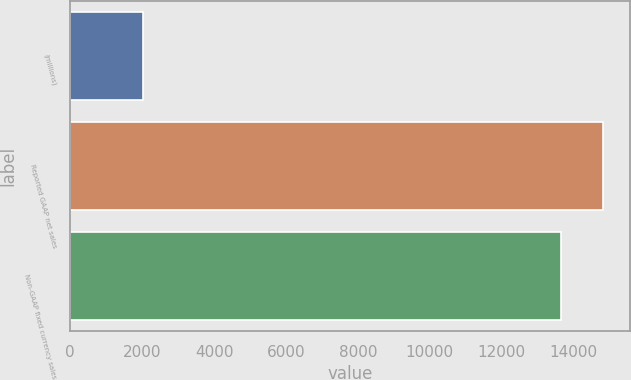Convert chart. <chart><loc_0><loc_0><loc_500><loc_500><bar_chart><fcel>(millions)<fcel>Reported GAAP net sales<fcel>Non-GAAP fixed currency sales<nl><fcel>2017<fcel>14828.3<fcel>13646.2<nl></chart> 